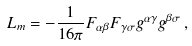<formula> <loc_0><loc_0><loc_500><loc_500>L _ { m } = - \frac { 1 } { 1 6 \pi } F _ { \alpha \beta } F _ { \gamma \sigma } g ^ { \alpha \gamma } g ^ { \beta \sigma } \, ,</formula> 